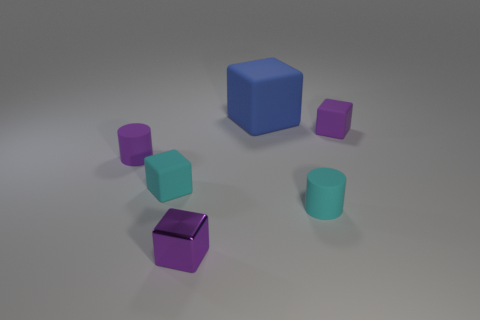The rubber cylinder that is the same color as the shiny cube is what size?
Your answer should be very brief. Small. There is a purple object that is both right of the tiny cyan block and behind the cyan rubber cylinder; what material is it made of?
Offer a very short reply. Rubber. There is a blue thing that is made of the same material as the small purple cylinder; what is its shape?
Provide a short and direct response. Cube. Are there any other things of the same color as the tiny shiny object?
Offer a terse response. Yes. Are there more small purple things behind the large blue rubber cube than tiny yellow rubber things?
Offer a terse response. No. What is the large block made of?
Provide a succinct answer. Rubber. What number of blue cubes are the same size as the metallic object?
Provide a succinct answer. 0. Are there an equal number of tiny purple matte things that are behind the blue cube and tiny purple metal things in front of the tiny metal thing?
Offer a very short reply. Yes. Does the blue block have the same material as the small cyan block?
Give a very brief answer. Yes. There is a purple block that is in front of the purple cylinder; are there any tiny cyan cylinders that are behind it?
Your answer should be very brief. Yes. 